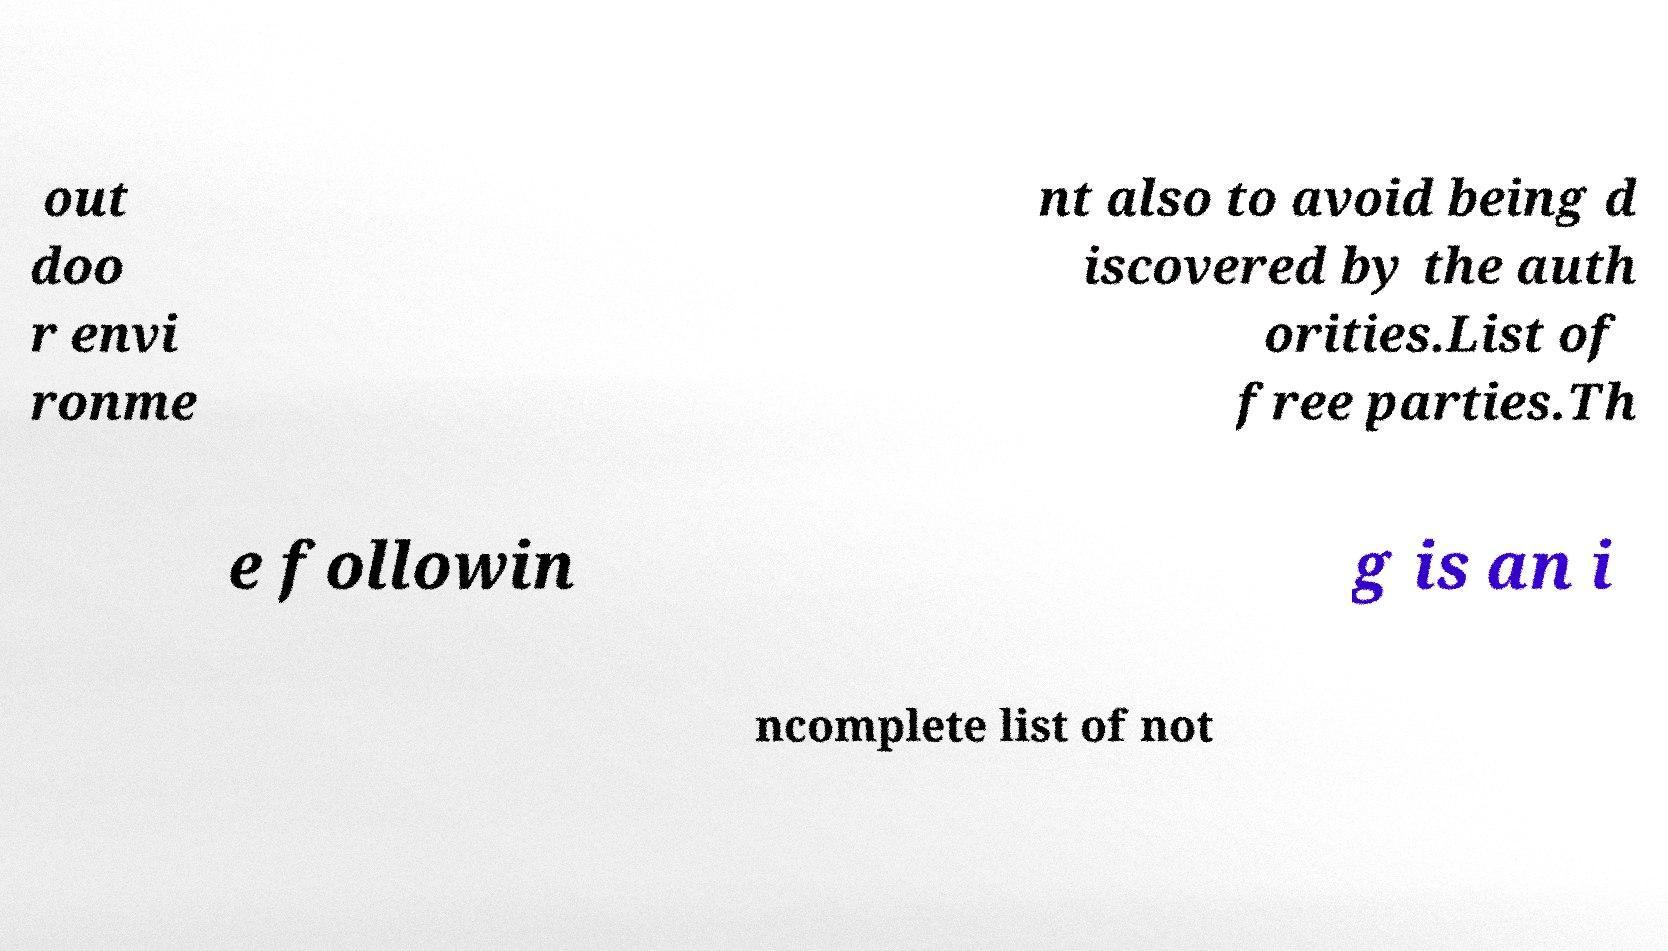Please identify and transcribe the text found in this image. out doo r envi ronme nt also to avoid being d iscovered by the auth orities.List of free parties.Th e followin g is an i ncomplete list of not 